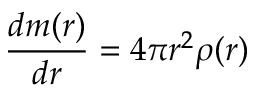<formula> <loc_0><loc_0><loc_500><loc_500>\frac { d m ( r ) } { d r } = 4 \pi r ^ { 2 } \rho ( r )</formula> 